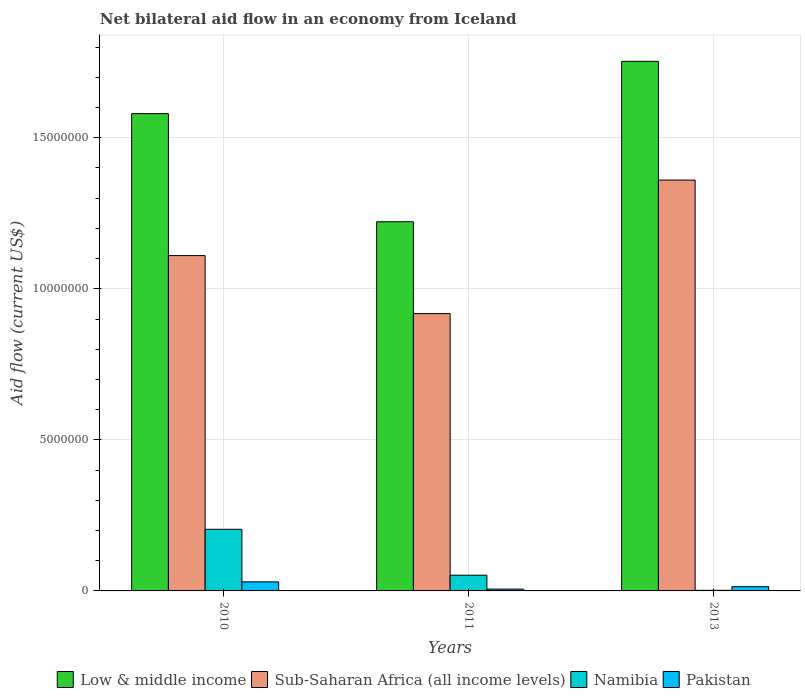What is the net bilateral aid flow in Low & middle income in 2010?
Provide a succinct answer. 1.58e+07. Across all years, what is the maximum net bilateral aid flow in Pakistan?
Your answer should be compact. 3.00e+05. Across all years, what is the minimum net bilateral aid flow in Low & middle income?
Your response must be concise. 1.22e+07. In which year was the net bilateral aid flow in Namibia minimum?
Give a very brief answer. 2013. What is the difference between the net bilateral aid flow in Namibia in 2010 and that in 2013?
Keep it short and to the point. 2.02e+06. What is the difference between the net bilateral aid flow in Pakistan in 2011 and the net bilateral aid flow in Namibia in 2013?
Your answer should be very brief. 4.00e+04. What is the average net bilateral aid flow in Namibia per year?
Keep it short and to the point. 8.60e+05. In the year 2011, what is the difference between the net bilateral aid flow in Sub-Saharan Africa (all income levels) and net bilateral aid flow in Pakistan?
Give a very brief answer. 9.12e+06. In how many years, is the net bilateral aid flow in Pakistan greater than 1000000 US$?
Offer a very short reply. 0. What is the ratio of the net bilateral aid flow in Low & middle income in 2010 to that in 2011?
Your answer should be very brief. 1.29. Is the net bilateral aid flow in Low & middle income in 2010 less than that in 2011?
Ensure brevity in your answer.  No. What is the difference between the highest and the second highest net bilateral aid flow in Pakistan?
Your response must be concise. 1.60e+05. Is the sum of the net bilateral aid flow in Low & middle income in 2010 and 2013 greater than the maximum net bilateral aid flow in Pakistan across all years?
Your answer should be compact. Yes. What does the 3rd bar from the left in 2010 represents?
Give a very brief answer. Namibia. What does the 3rd bar from the right in 2010 represents?
Make the answer very short. Sub-Saharan Africa (all income levels). How many bars are there?
Your answer should be compact. 12. How many years are there in the graph?
Provide a short and direct response. 3. What is the difference between two consecutive major ticks on the Y-axis?
Your response must be concise. 5.00e+06. Are the values on the major ticks of Y-axis written in scientific E-notation?
Give a very brief answer. No. Does the graph contain any zero values?
Your answer should be compact. No. Does the graph contain grids?
Ensure brevity in your answer.  Yes. What is the title of the graph?
Keep it short and to the point. Net bilateral aid flow in an economy from Iceland. What is the label or title of the X-axis?
Provide a succinct answer. Years. What is the Aid flow (current US$) of Low & middle income in 2010?
Provide a succinct answer. 1.58e+07. What is the Aid flow (current US$) of Sub-Saharan Africa (all income levels) in 2010?
Ensure brevity in your answer.  1.11e+07. What is the Aid flow (current US$) of Namibia in 2010?
Your answer should be very brief. 2.04e+06. What is the Aid flow (current US$) in Low & middle income in 2011?
Provide a short and direct response. 1.22e+07. What is the Aid flow (current US$) in Sub-Saharan Africa (all income levels) in 2011?
Make the answer very short. 9.18e+06. What is the Aid flow (current US$) in Namibia in 2011?
Ensure brevity in your answer.  5.20e+05. What is the Aid flow (current US$) of Pakistan in 2011?
Give a very brief answer. 6.00e+04. What is the Aid flow (current US$) of Low & middle income in 2013?
Provide a short and direct response. 1.75e+07. What is the Aid flow (current US$) in Sub-Saharan Africa (all income levels) in 2013?
Provide a short and direct response. 1.36e+07. What is the Aid flow (current US$) in Namibia in 2013?
Your answer should be very brief. 2.00e+04. Across all years, what is the maximum Aid flow (current US$) of Low & middle income?
Ensure brevity in your answer.  1.75e+07. Across all years, what is the maximum Aid flow (current US$) of Sub-Saharan Africa (all income levels)?
Keep it short and to the point. 1.36e+07. Across all years, what is the maximum Aid flow (current US$) in Namibia?
Your answer should be compact. 2.04e+06. Across all years, what is the maximum Aid flow (current US$) in Pakistan?
Your answer should be very brief. 3.00e+05. Across all years, what is the minimum Aid flow (current US$) of Low & middle income?
Your response must be concise. 1.22e+07. Across all years, what is the minimum Aid flow (current US$) of Sub-Saharan Africa (all income levels)?
Your answer should be compact. 9.18e+06. Across all years, what is the minimum Aid flow (current US$) in Pakistan?
Your response must be concise. 6.00e+04. What is the total Aid flow (current US$) of Low & middle income in the graph?
Your answer should be very brief. 4.56e+07. What is the total Aid flow (current US$) in Sub-Saharan Africa (all income levels) in the graph?
Your answer should be compact. 3.39e+07. What is the total Aid flow (current US$) of Namibia in the graph?
Offer a terse response. 2.58e+06. What is the total Aid flow (current US$) in Pakistan in the graph?
Make the answer very short. 5.00e+05. What is the difference between the Aid flow (current US$) in Low & middle income in 2010 and that in 2011?
Provide a succinct answer. 3.58e+06. What is the difference between the Aid flow (current US$) of Sub-Saharan Africa (all income levels) in 2010 and that in 2011?
Provide a short and direct response. 1.92e+06. What is the difference between the Aid flow (current US$) in Namibia in 2010 and that in 2011?
Your answer should be compact. 1.52e+06. What is the difference between the Aid flow (current US$) in Low & middle income in 2010 and that in 2013?
Offer a very short reply. -1.73e+06. What is the difference between the Aid flow (current US$) in Sub-Saharan Africa (all income levels) in 2010 and that in 2013?
Provide a succinct answer. -2.50e+06. What is the difference between the Aid flow (current US$) in Namibia in 2010 and that in 2013?
Your answer should be compact. 2.02e+06. What is the difference between the Aid flow (current US$) of Pakistan in 2010 and that in 2013?
Keep it short and to the point. 1.60e+05. What is the difference between the Aid flow (current US$) of Low & middle income in 2011 and that in 2013?
Ensure brevity in your answer.  -5.31e+06. What is the difference between the Aid flow (current US$) of Sub-Saharan Africa (all income levels) in 2011 and that in 2013?
Make the answer very short. -4.42e+06. What is the difference between the Aid flow (current US$) in Namibia in 2011 and that in 2013?
Provide a short and direct response. 5.00e+05. What is the difference between the Aid flow (current US$) in Pakistan in 2011 and that in 2013?
Provide a succinct answer. -8.00e+04. What is the difference between the Aid flow (current US$) in Low & middle income in 2010 and the Aid flow (current US$) in Sub-Saharan Africa (all income levels) in 2011?
Give a very brief answer. 6.62e+06. What is the difference between the Aid flow (current US$) of Low & middle income in 2010 and the Aid flow (current US$) of Namibia in 2011?
Provide a short and direct response. 1.53e+07. What is the difference between the Aid flow (current US$) of Low & middle income in 2010 and the Aid flow (current US$) of Pakistan in 2011?
Give a very brief answer. 1.57e+07. What is the difference between the Aid flow (current US$) of Sub-Saharan Africa (all income levels) in 2010 and the Aid flow (current US$) of Namibia in 2011?
Provide a short and direct response. 1.06e+07. What is the difference between the Aid flow (current US$) of Sub-Saharan Africa (all income levels) in 2010 and the Aid flow (current US$) of Pakistan in 2011?
Offer a terse response. 1.10e+07. What is the difference between the Aid flow (current US$) in Namibia in 2010 and the Aid flow (current US$) in Pakistan in 2011?
Your answer should be compact. 1.98e+06. What is the difference between the Aid flow (current US$) of Low & middle income in 2010 and the Aid flow (current US$) of Sub-Saharan Africa (all income levels) in 2013?
Your answer should be compact. 2.20e+06. What is the difference between the Aid flow (current US$) in Low & middle income in 2010 and the Aid flow (current US$) in Namibia in 2013?
Your answer should be very brief. 1.58e+07. What is the difference between the Aid flow (current US$) of Low & middle income in 2010 and the Aid flow (current US$) of Pakistan in 2013?
Your response must be concise. 1.57e+07. What is the difference between the Aid flow (current US$) in Sub-Saharan Africa (all income levels) in 2010 and the Aid flow (current US$) in Namibia in 2013?
Your response must be concise. 1.11e+07. What is the difference between the Aid flow (current US$) in Sub-Saharan Africa (all income levels) in 2010 and the Aid flow (current US$) in Pakistan in 2013?
Make the answer very short. 1.10e+07. What is the difference between the Aid flow (current US$) of Namibia in 2010 and the Aid flow (current US$) of Pakistan in 2013?
Give a very brief answer. 1.90e+06. What is the difference between the Aid flow (current US$) in Low & middle income in 2011 and the Aid flow (current US$) in Sub-Saharan Africa (all income levels) in 2013?
Offer a terse response. -1.38e+06. What is the difference between the Aid flow (current US$) of Low & middle income in 2011 and the Aid flow (current US$) of Namibia in 2013?
Keep it short and to the point. 1.22e+07. What is the difference between the Aid flow (current US$) of Low & middle income in 2011 and the Aid flow (current US$) of Pakistan in 2013?
Your response must be concise. 1.21e+07. What is the difference between the Aid flow (current US$) of Sub-Saharan Africa (all income levels) in 2011 and the Aid flow (current US$) of Namibia in 2013?
Your answer should be very brief. 9.16e+06. What is the difference between the Aid flow (current US$) in Sub-Saharan Africa (all income levels) in 2011 and the Aid flow (current US$) in Pakistan in 2013?
Give a very brief answer. 9.04e+06. What is the difference between the Aid flow (current US$) of Namibia in 2011 and the Aid flow (current US$) of Pakistan in 2013?
Provide a succinct answer. 3.80e+05. What is the average Aid flow (current US$) in Low & middle income per year?
Ensure brevity in your answer.  1.52e+07. What is the average Aid flow (current US$) of Sub-Saharan Africa (all income levels) per year?
Your answer should be compact. 1.13e+07. What is the average Aid flow (current US$) in Namibia per year?
Offer a very short reply. 8.60e+05. What is the average Aid flow (current US$) in Pakistan per year?
Provide a short and direct response. 1.67e+05. In the year 2010, what is the difference between the Aid flow (current US$) in Low & middle income and Aid flow (current US$) in Sub-Saharan Africa (all income levels)?
Offer a very short reply. 4.70e+06. In the year 2010, what is the difference between the Aid flow (current US$) of Low & middle income and Aid flow (current US$) of Namibia?
Ensure brevity in your answer.  1.38e+07. In the year 2010, what is the difference between the Aid flow (current US$) in Low & middle income and Aid flow (current US$) in Pakistan?
Your answer should be compact. 1.55e+07. In the year 2010, what is the difference between the Aid flow (current US$) of Sub-Saharan Africa (all income levels) and Aid flow (current US$) of Namibia?
Your answer should be very brief. 9.06e+06. In the year 2010, what is the difference between the Aid flow (current US$) in Sub-Saharan Africa (all income levels) and Aid flow (current US$) in Pakistan?
Make the answer very short. 1.08e+07. In the year 2010, what is the difference between the Aid flow (current US$) in Namibia and Aid flow (current US$) in Pakistan?
Your answer should be compact. 1.74e+06. In the year 2011, what is the difference between the Aid flow (current US$) in Low & middle income and Aid flow (current US$) in Sub-Saharan Africa (all income levels)?
Make the answer very short. 3.04e+06. In the year 2011, what is the difference between the Aid flow (current US$) of Low & middle income and Aid flow (current US$) of Namibia?
Your answer should be very brief. 1.17e+07. In the year 2011, what is the difference between the Aid flow (current US$) in Low & middle income and Aid flow (current US$) in Pakistan?
Provide a succinct answer. 1.22e+07. In the year 2011, what is the difference between the Aid flow (current US$) of Sub-Saharan Africa (all income levels) and Aid flow (current US$) of Namibia?
Your answer should be very brief. 8.66e+06. In the year 2011, what is the difference between the Aid flow (current US$) of Sub-Saharan Africa (all income levels) and Aid flow (current US$) of Pakistan?
Provide a short and direct response. 9.12e+06. In the year 2011, what is the difference between the Aid flow (current US$) of Namibia and Aid flow (current US$) of Pakistan?
Give a very brief answer. 4.60e+05. In the year 2013, what is the difference between the Aid flow (current US$) of Low & middle income and Aid flow (current US$) of Sub-Saharan Africa (all income levels)?
Provide a succinct answer. 3.93e+06. In the year 2013, what is the difference between the Aid flow (current US$) in Low & middle income and Aid flow (current US$) in Namibia?
Offer a very short reply. 1.75e+07. In the year 2013, what is the difference between the Aid flow (current US$) of Low & middle income and Aid flow (current US$) of Pakistan?
Offer a very short reply. 1.74e+07. In the year 2013, what is the difference between the Aid flow (current US$) in Sub-Saharan Africa (all income levels) and Aid flow (current US$) in Namibia?
Your response must be concise. 1.36e+07. In the year 2013, what is the difference between the Aid flow (current US$) of Sub-Saharan Africa (all income levels) and Aid flow (current US$) of Pakistan?
Provide a succinct answer. 1.35e+07. What is the ratio of the Aid flow (current US$) in Low & middle income in 2010 to that in 2011?
Offer a terse response. 1.29. What is the ratio of the Aid flow (current US$) of Sub-Saharan Africa (all income levels) in 2010 to that in 2011?
Make the answer very short. 1.21. What is the ratio of the Aid flow (current US$) in Namibia in 2010 to that in 2011?
Ensure brevity in your answer.  3.92. What is the ratio of the Aid flow (current US$) of Pakistan in 2010 to that in 2011?
Give a very brief answer. 5. What is the ratio of the Aid flow (current US$) in Low & middle income in 2010 to that in 2013?
Keep it short and to the point. 0.9. What is the ratio of the Aid flow (current US$) of Sub-Saharan Africa (all income levels) in 2010 to that in 2013?
Ensure brevity in your answer.  0.82. What is the ratio of the Aid flow (current US$) in Namibia in 2010 to that in 2013?
Your response must be concise. 102. What is the ratio of the Aid flow (current US$) in Pakistan in 2010 to that in 2013?
Your answer should be very brief. 2.14. What is the ratio of the Aid flow (current US$) in Low & middle income in 2011 to that in 2013?
Provide a short and direct response. 0.7. What is the ratio of the Aid flow (current US$) in Sub-Saharan Africa (all income levels) in 2011 to that in 2013?
Offer a terse response. 0.68. What is the ratio of the Aid flow (current US$) in Pakistan in 2011 to that in 2013?
Provide a short and direct response. 0.43. What is the difference between the highest and the second highest Aid flow (current US$) in Low & middle income?
Provide a short and direct response. 1.73e+06. What is the difference between the highest and the second highest Aid flow (current US$) of Sub-Saharan Africa (all income levels)?
Provide a short and direct response. 2.50e+06. What is the difference between the highest and the second highest Aid flow (current US$) in Namibia?
Offer a terse response. 1.52e+06. What is the difference between the highest and the lowest Aid flow (current US$) of Low & middle income?
Keep it short and to the point. 5.31e+06. What is the difference between the highest and the lowest Aid flow (current US$) of Sub-Saharan Africa (all income levels)?
Provide a short and direct response. 4.42e+06. What is the difference between the highest and the lowest Aid flow (current US$) in Namibia?
Your answer should be very brief. 2.02e+06. 